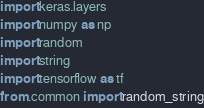<code> <loc_0><loc_0><loc_500><loc_500><_Python_>import keras.layers
import numpy as np
import random
import string
import tensorflow as tf
from .common import random_string

</code> 